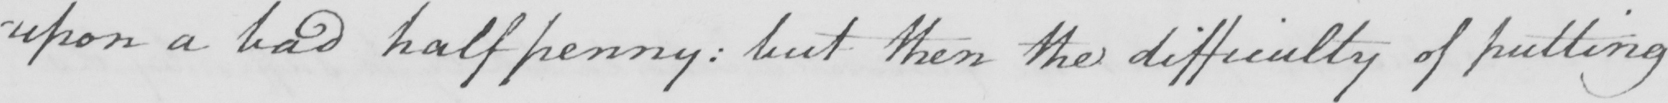Please transcribe the handwritten text in this image. upon a bad halfpenny :  but then the difficulty of putting 